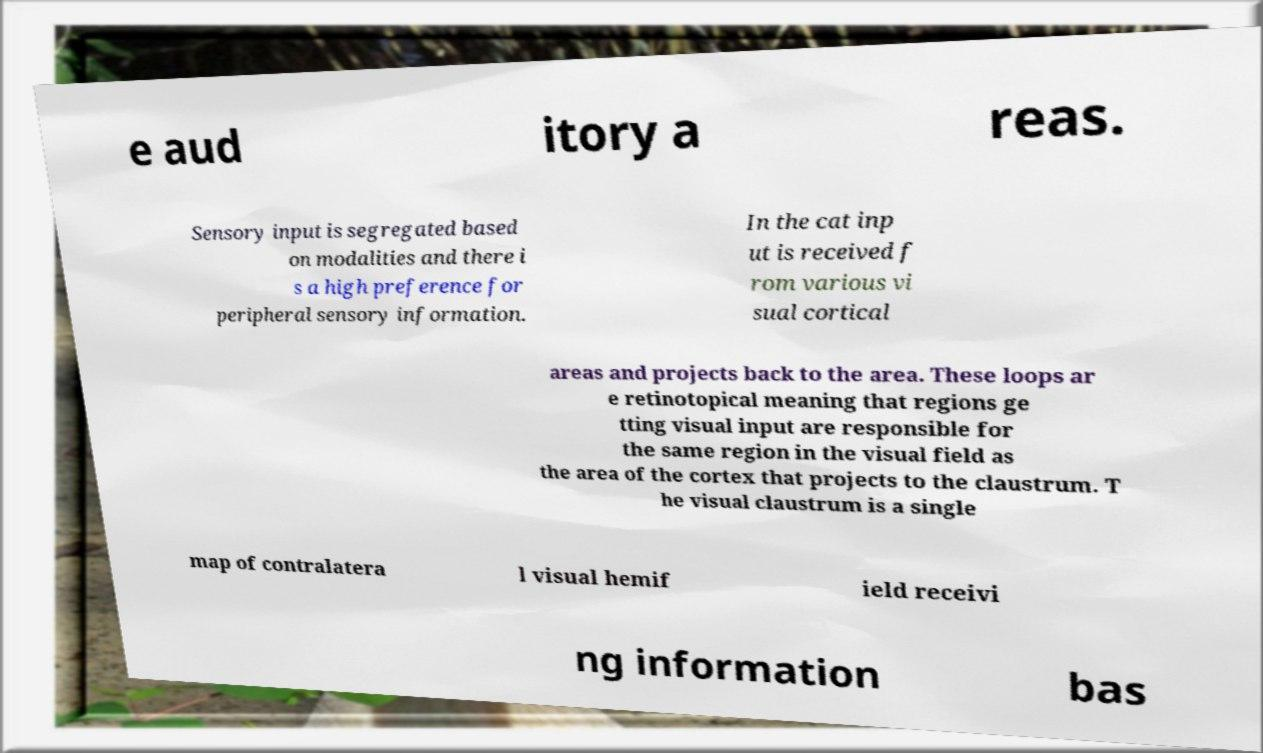Please identify and transcribe the text found in this image. e aud itory a reas. Sensory input is segregated based on modalities and there i s a high preference for peripheral sensory information. In the cat inp ut is received f rom various vi sual cortical areas and projects back to the area. These loops ar e retinotopical meaning that regions ge tting visual input are responsible for the same region in the visual field as the area of the cortex that projects to the claustrum. T he visual claustrum is a single map of contralatera l visual hemif ield receivi ng information bas 